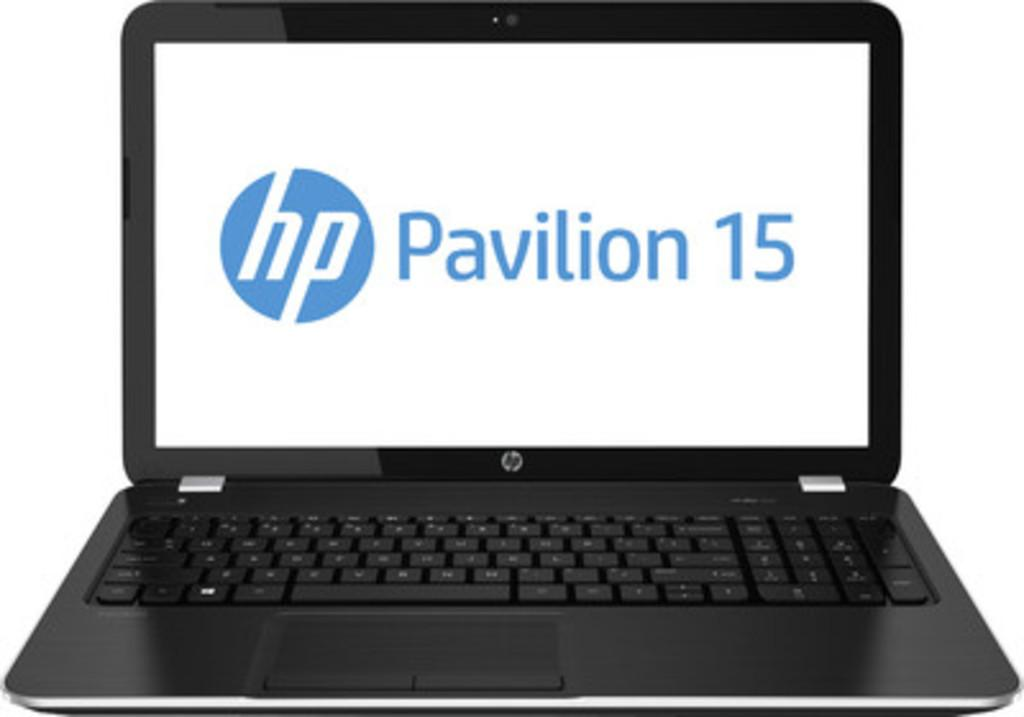<image>
Render a clear and concise summary of the photo. A Pavilion 15 laptop that is made by HP. 